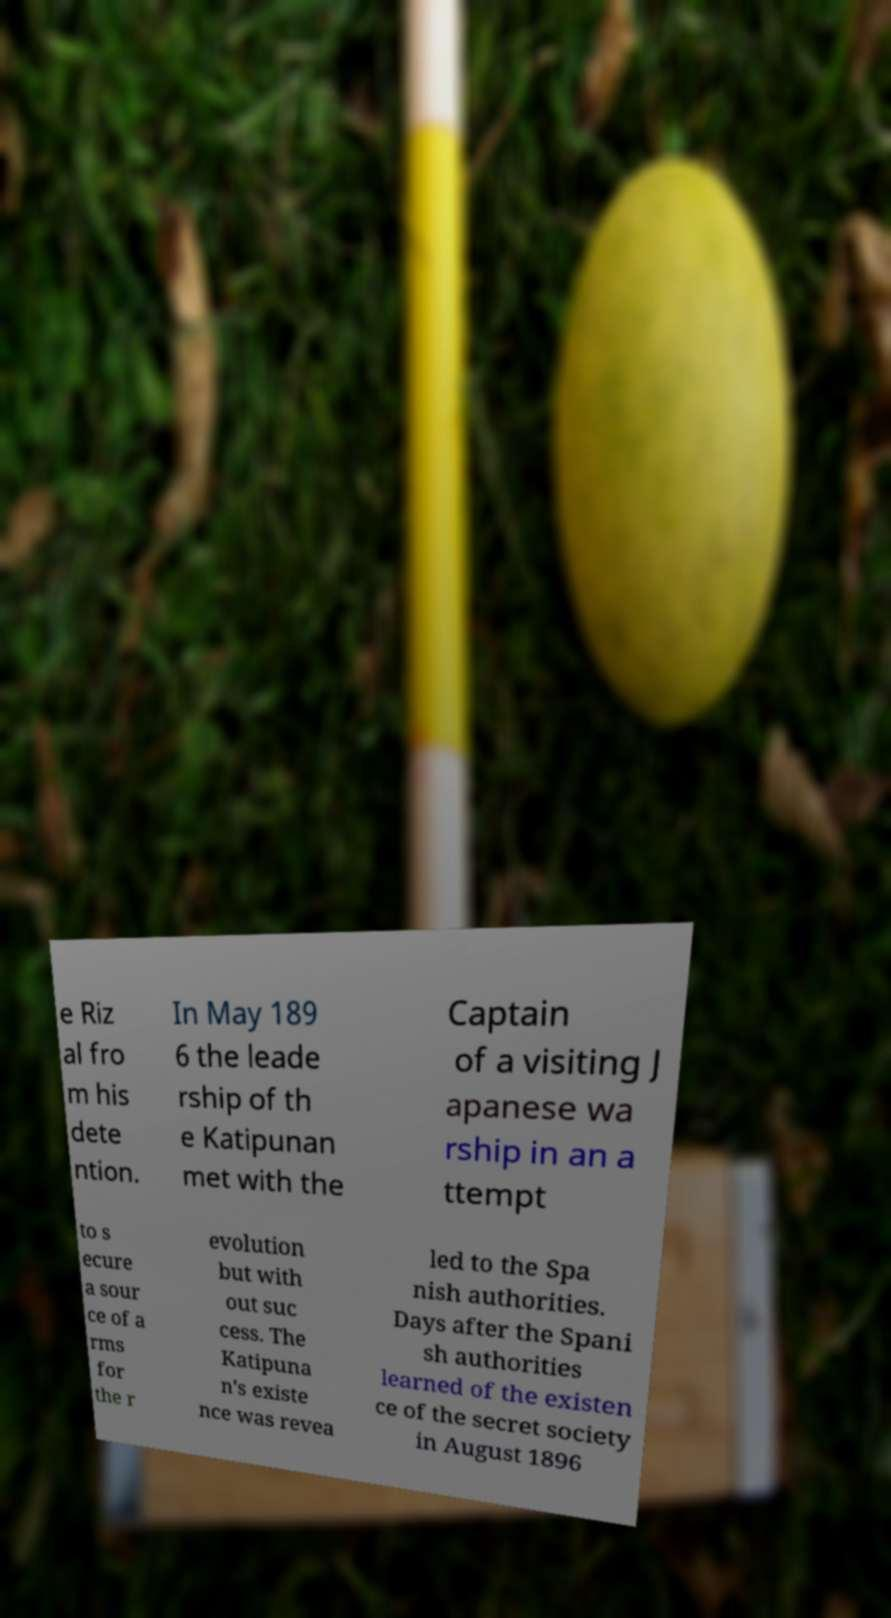I need the written content from this picture converted into text. Can you do that? e Riz al fro m his dete ntion. In May 189 6 the leade rship of th e Katipunan met with the Captain of a visiting J apanese wa rship in an a ttempt to s ecure a sour ce of a rms for the r evolution but with out suc cess. The Katipuna n's existe nce was revea led to the Spa nish authorities. Days after the Spani sh authorities learned of the existen ce of the secret society in August 1896 